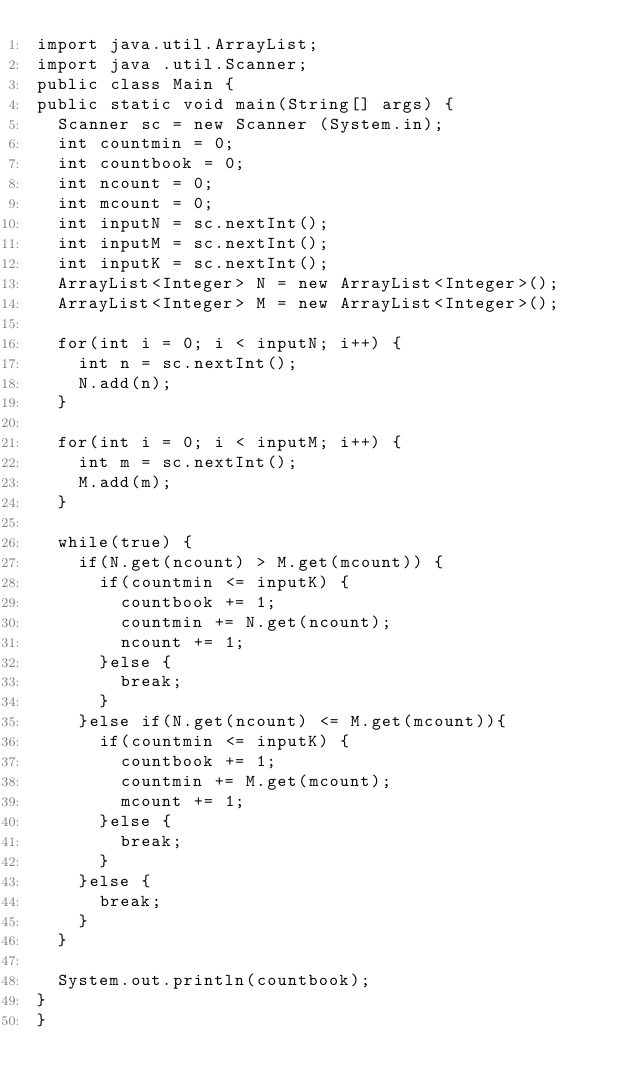<code> <loc_0><loc_0><loc_500><loc_500><_Java_>import java.util.ArrayList;
import java .util.Scanner;
public class Main {
public static void main(String[] args) {
	Scanner sc = new Scanner (System.in);
	int countmin = 0;
	int countbook = 0;
	int ncount = 0;
	int mcount = 0;
	int inputN = sc.nextInt();
	int inputM = sc.nextInt();
	int inputK = sc.nextInt();
	ArrayList<Integer> N = new ArrayList<Integer>();
	ArrayList<Integer> M = new ArrayList<Integer>();

	for(int i = 0; i < inputN; i++) {
		int n = sc.nextInt();
		N.add(n);
	}

	for(int i = 0; i < inputM; i++) {
		int m = sc.nextInt();
		M.add(m);
	}

	while(true) {
		if(N.get(ncount) > M.get(mcount)) {
			if(countmin <= inputK) {
				countbook += 1;
				countmin += N.get(ncount);
				ncount += 1;
			}else {
				break;
			}
		}else if(N.get(ncount) <= M.get(mcount)){
			if(countmin <= inputK) {
				countbook += 1;
				countmin += M.get(mcount);
				mcount += 1;
			}else {
				break;
			}
		}else {
			break;
		}
	}

	System.out.println(countbook);
}
}</code> 